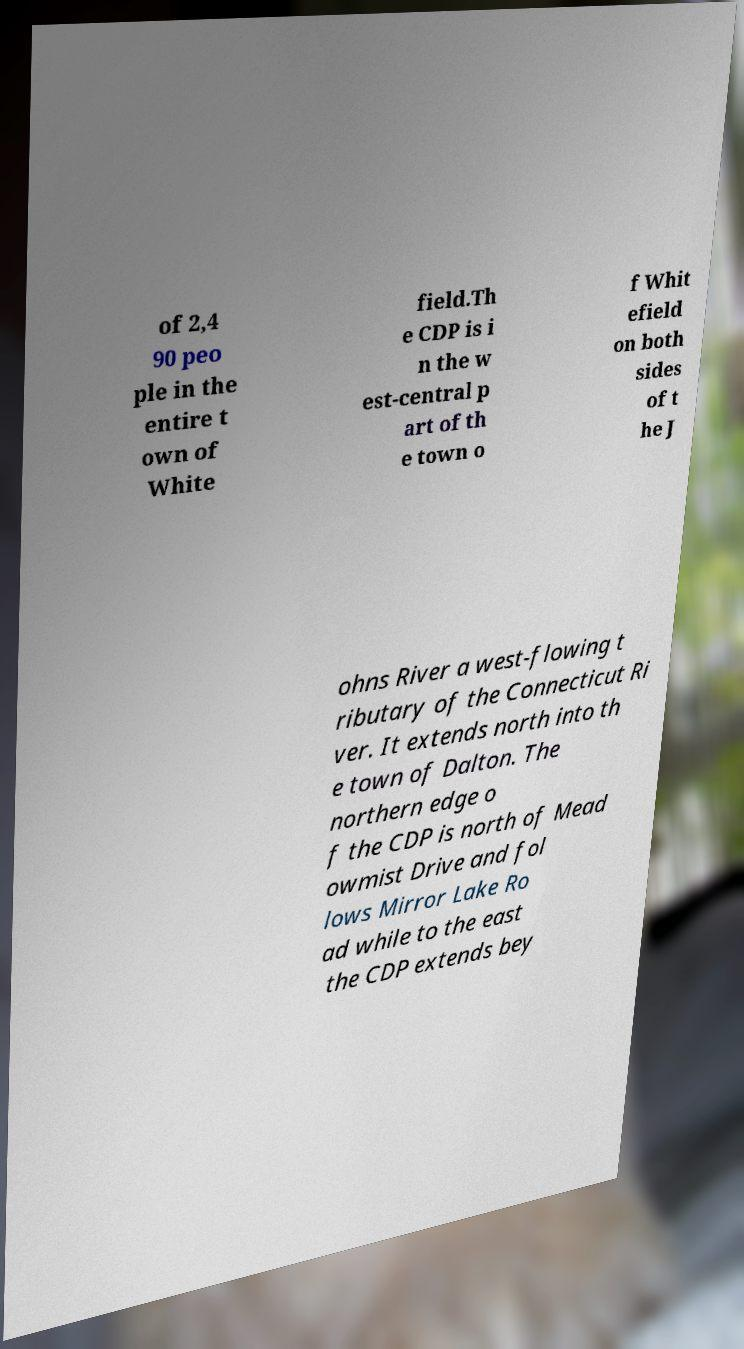For documentation purposes, I need the text within this image transcribed. Could you provide that? of 2,4 90 peo ple in the entire t own of White field.Th e CDP is i n the w est-central p art of th e town o f Whit efield on both sides of t he J ohns River a west-flowing t ributary of the Connecticut Ri ver. It extends north into th e town of Dalton. The northern edge o f the CDP is north of Mead owmist Drive and fol lows Mirror Lake Ro ad while to the east the CDP extends bey 